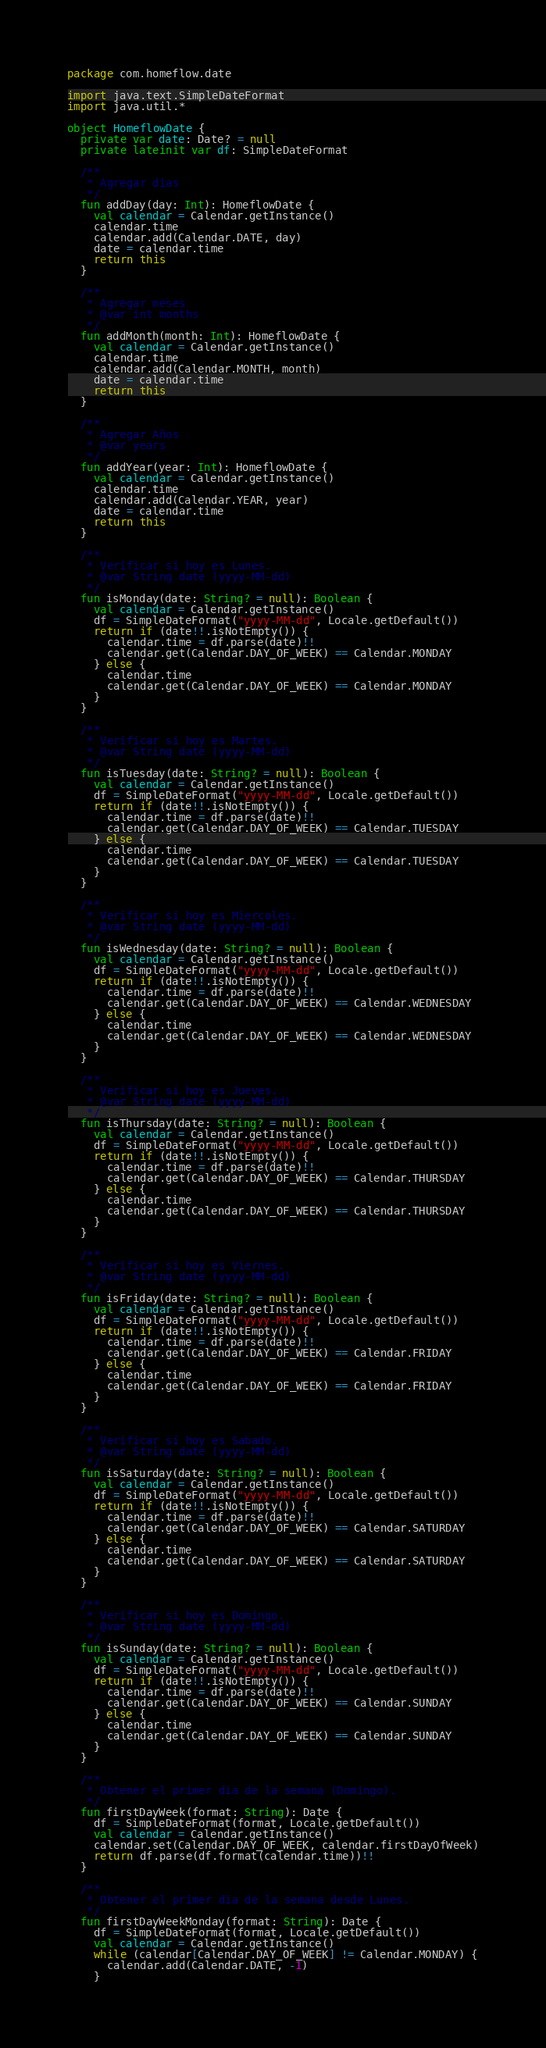<code> <loc_0><loc_0><loc_500><loc_500><_Kotlin_>package com.homeflow.date

import java.text.SimpleDateFormat
import java.util.*

object HomeflowDate {
  private var date: Date? = null
  private lateinit var df: SimpleDateFormat

  /**
   * Agregar dias
   */
  fun addDay(day: Int): HomeflowDate {
    val calendar = Calendar.getInstance()
    calendar.time
    calendar.add(Calendar.DATE, day)
    date = calendar.time
    return this
  }

  /**
   * Agregar meses
   * @var int months
   */
  fun addMonth(month: Int): HomeflowDate {
    val calendar = Calendar.getInstance()
    calendar.time
    calendar.add(Calendar.MONTH, month)
    date = calendar.time
    return this
  }

  /**
   * Agregar Años
   * @var years
   */
  fun addYear(year: Int): HomeflowDate {
    val calendar = Calendar.getInstance()
    calendar.time
    calendar.add(Calendar.YEAR, year)
    date = calendar.time
    return this
  }

  /**
   * Verificar si hoy es Lunes.
   * @var String date (yyyy-MM-dd)
   */
  fun isMonday(date: String? = null): Boolean {
    val calendar = Calendar.getInstance()
    df = SimpleDateFormat("yyyy-MM-dd", Locale.getDefault())
    return if (date!!.isNotEmpty()) {
      calendar.time = df.parse(date)!!
      calendar.get(Calendar.DAY_OF_WEEK) == Calendar.MONDAY
    } else {
      calendar.time
      calendar.get(Calendar.DAY_OF_WEEK) == Calendar.MONDAY
    }
  }

  /**
   * Verificar si hoy es Martes.
   * @var String date (yyyy-MM-dd)
   */
  fun isTuesday(date: String? = null): Boolean {
    val calendar = Calendar.getInstance()
    df = SimpleDateFormat("yyyy-MM-dd", Locale.getDefault())
    return if (date!!.isNotEmpty()) {
      calendar.time = df.parse(date)!!
      calendar.get(Calendar.DAY_OF_WEEK) == Calendar.TUESDAY
    } else {
      calendar.time
      calendar.get(Calendar.DAY_OF_WEEK) == Calendar.TUESDAY
    }
  }

  /**
   * Verificar si hoy es Miercoles.
   * @var String date (yyyy-MM-dd)
   */
  fun isWednesday(date: String? = null): Boolean {
    val calendar = Calendar.getInstance()
    df = SimpleDateFormat("yyyy-MM-dd", Locale.getDefault())
    return if (date!!.isNotEmpty()) {
      calendar.time = df.parse(date)!!
      calendar.get(Calendar.DAY_OF_WEEK) == Calendar.WEDNESDAY
    } else {
      calendar.time
      calendar.get(Calendar.DAY_OF_WEEK) == Calendar.WEDNESDAY
    }
  }

  /**
   * Verificar si hoy es Jueves.
   * @var String date (yyyy-MM-dd)
   */
  fun isThursday(date: String? = null): Boolean {
    val calendar = Calendar.getInstance()
    df = SimpleDateFormat("yyyy-MM-dd", Locale.getDefault())
    return if (date!!.isNotEmpty()) {
      calendar.time = df.parse(date)!!
      calendar.get(Calendar.DAY_OF_WEEK) == Calendar.THURSDAY
    } else {
      calendar.time
      calendar.get(Calendar.DAY_OF_WEEK) == Calendar.THURSDAY
    }
  }

  /**
   * Verificar si hoy es Viernes.
   * @var String date (yyyy-MM-dd)
   */
  fun isFriday(date: String? = null): Boolean {
    val calendar = Calendar.getInstance()
    df = SimpleDateFormat("yyyy-MM-dd", Locale.getDefault())
    return if (date!!.isNotEmpty()) {
      calendar.time = df.parse(date)!!
      calendar.get(Calendar.DAY_OF_WEEK) == Calendar.FRIDAY
    } else {
      calendar.time
      calendar.get(Calendar.DAY_OF_WEEK) == Calendar.FRIDAY
    }
  }

  /**
   * Verificar si hoy es Sabado.
   * @var String date (yyyy-MM-dd)
   */
  fun isSaturday(date: String? = null): Boolean {
    val calendar = Calendar.getInstance()
    df = SimpleDateFormat("yyyy-MM-dd", Locale.getDefault())
    return if (date!!.isNotEmpty()) {
      calendar.time = df.parse(date)!!
      calendar.get(Calendar.DAY_OF_WEEK) == Calendar.SATURDAY
    } else {
      calendar.time
      calendar.get(Calendar.DAY_OF_WEEK) == Calendar.SATURDAY
    }
  }

  /**
   * Verificar si hoy es Domingo.
   * @var String date (yyyy-MM-dd)
   */
  fun isSunday(date: String? = null): Boolean {
    val calendar = Calendar.getInstance()
    df = SimpleDateFormat("yyyy-MM-dd", Locale.getDefault())
    return if (date!!.isNotEmpty()) {
      calendar.time = df.parse(date)!!
      calendar.get(Calendar.DAY_OF_WEEK) == Calendar.SUNDAY
    } else {
      calendar.time
      calendar.get(Calendar.DAY_OF_WEEK) == Calendar.SUNDAY
    }
  }

  /**
   * Obtener el primer dia de la semana (Domingo).
   */
  fun firstDayWeek(format: String): Date {
    df = SimpleDateFormat(format, Locale.getDefault())
    val calendar = Calendar.getInstance()
    calendar.set(Calendar.DAY_OF_WEEK, calendar.firstDayOfWeek)
    return df.parse(df.format(calendar.time))!!
  }

  /**
   * Obtener el primer dia de la semana desde Lunes.
   */
  fun firstDayWeekMonday(format: String): Date {
    df = SimpleDateFormat(format, Locale.getDefault())
    val calendar = Calendar.getInstance()
    while (calendar[Calendar.DAY_OF_WEEK] != Calendar.MONDAY) {
      calendar.add(Calendar.DATE, -1)
    }</code> 